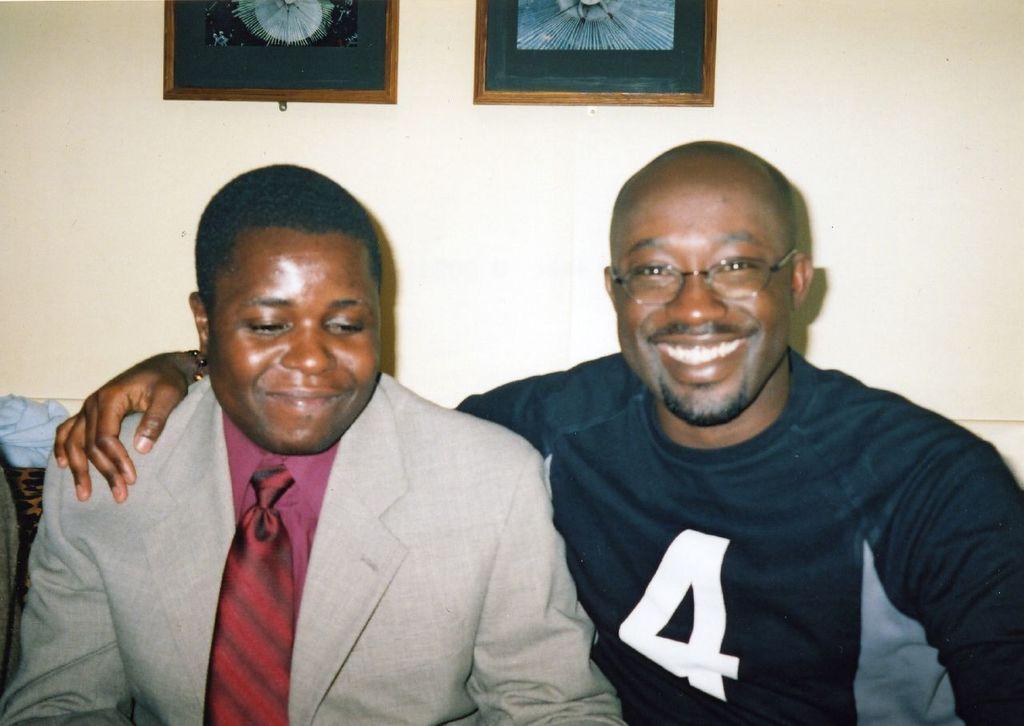Can you describe this image briefly? In this image, we can see people sitting and one of them is wearing a tie and the other is wearing glasses and smiling. In the background, there are frames placed on the wall and we can see an object. 